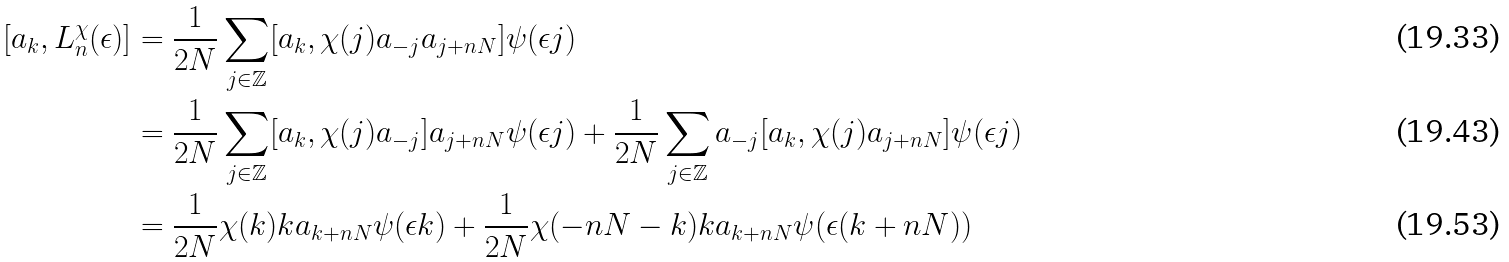Convert formula to latex. <formula><loc_0><loc_0><loc_500><loc_500>[ a _ { k } , L _ { n } ^ { \chi } ( \epsilon ) ] & = \frac { 1 } { 2 N } \sum _ { j \in \mathbb { Z } } [ a _ { k } , \chi ( j ) a _ { - j } a _ { j + n N } ] \psi ( \epsilon j ) \\ & = \frac { 1 } { 2 N } \sum _ { j \in \mathbb { Z } } [ a _ { k } , \chi ( j ) a _ { - j } ] a _ { j + n N } \psi ( \epsilon j ) + \frac { 1 } { 2 N } \sum _ { j \in \mathbb { Z } } a _ { - j } [ a _ { k } , \chi ( j ) a _ { j + n N } ] \psi ( \epsilon j ) \\ & = \frac { 1 } { 2 N } \chi ( k ) k a _ { k + n N } \psi ( \epsilon k ) + \frac { 1 } { 2 N } \chi ( - n N - k ) k a _ { k + n N } \psi ( \epsilon ( k + n N ) )</formula> 